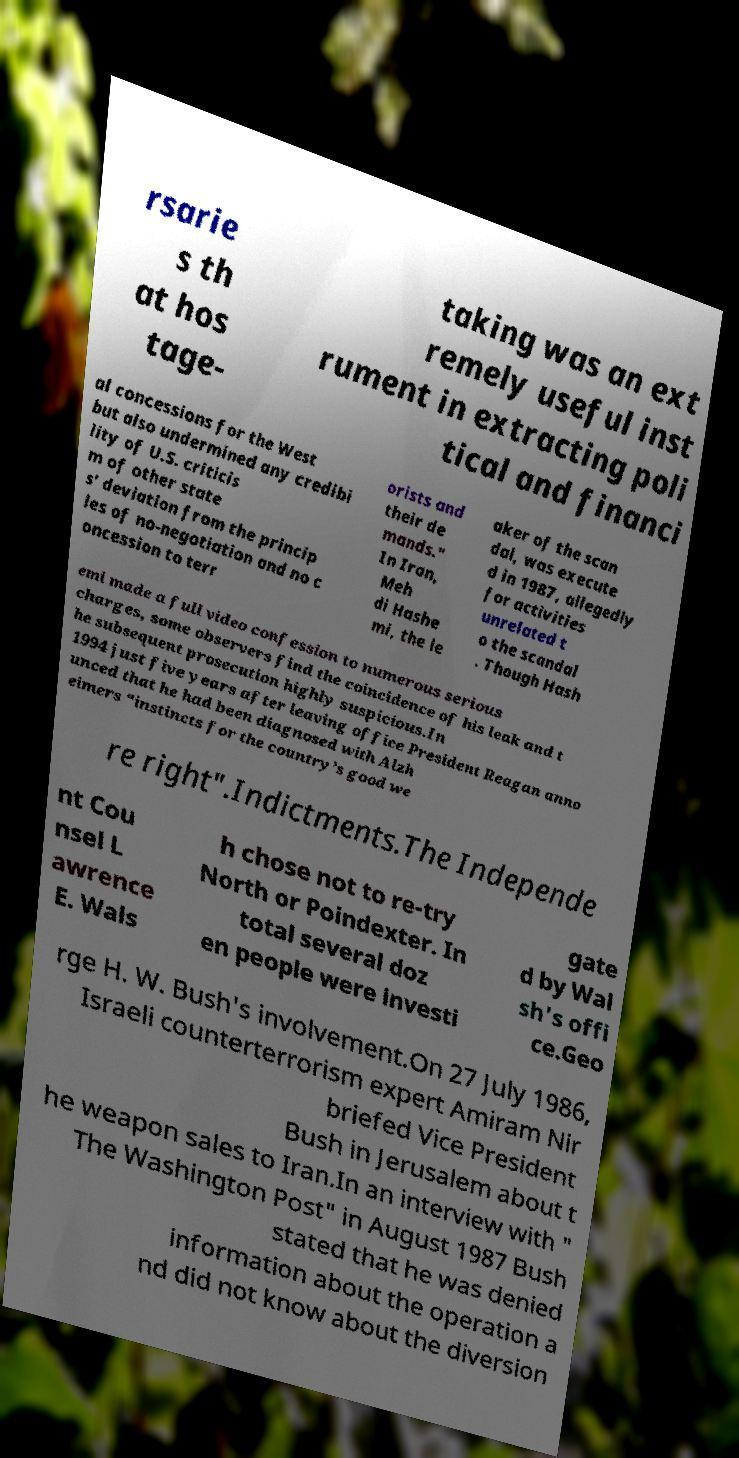Can you accurately transcribe the text from the provided image for me? rsarie s th at hos tage- taking was an ext remely useful inst rument in extracting poli tical and financi al concessions for the West but also undermined any credibi lity of U.S. criticis m of other state s' deviation from the princip les of no-negotiation and no c oncession to terr orists and their de mands." In Iran, Meh di Hashe mi, the le aker of the scan dal, was execute d in 1987, allegedly for activities unrelated t o the scandal . Though Hash emi made a full video confession to numerous serious charges, some observers find the coincidence of his leak and t he subsequent prosecution highly suspicious.In 1994 just five years after leaving office President Reagan anno unced that he had been diagnosed with Alzh eimers “instincts for the country’s good we re right".Indictments.The Independe nt Cou nsel L awrence E. Wals h chose not to re-try North or Poindexter. In total several doz en people were investi gate d by Wal sh's offi ce.Geo rge H. W. Bush's involvement.On 27 July 1986, Israeli counterterrorism expert Amiram Nir briefed Vice President Bush in Jerusalem about t he weapon sales to Iran.In an interview with " The Washington Post" in August 1987 Bush stated that he was denied information about the operation a nd did not know about the diversion 